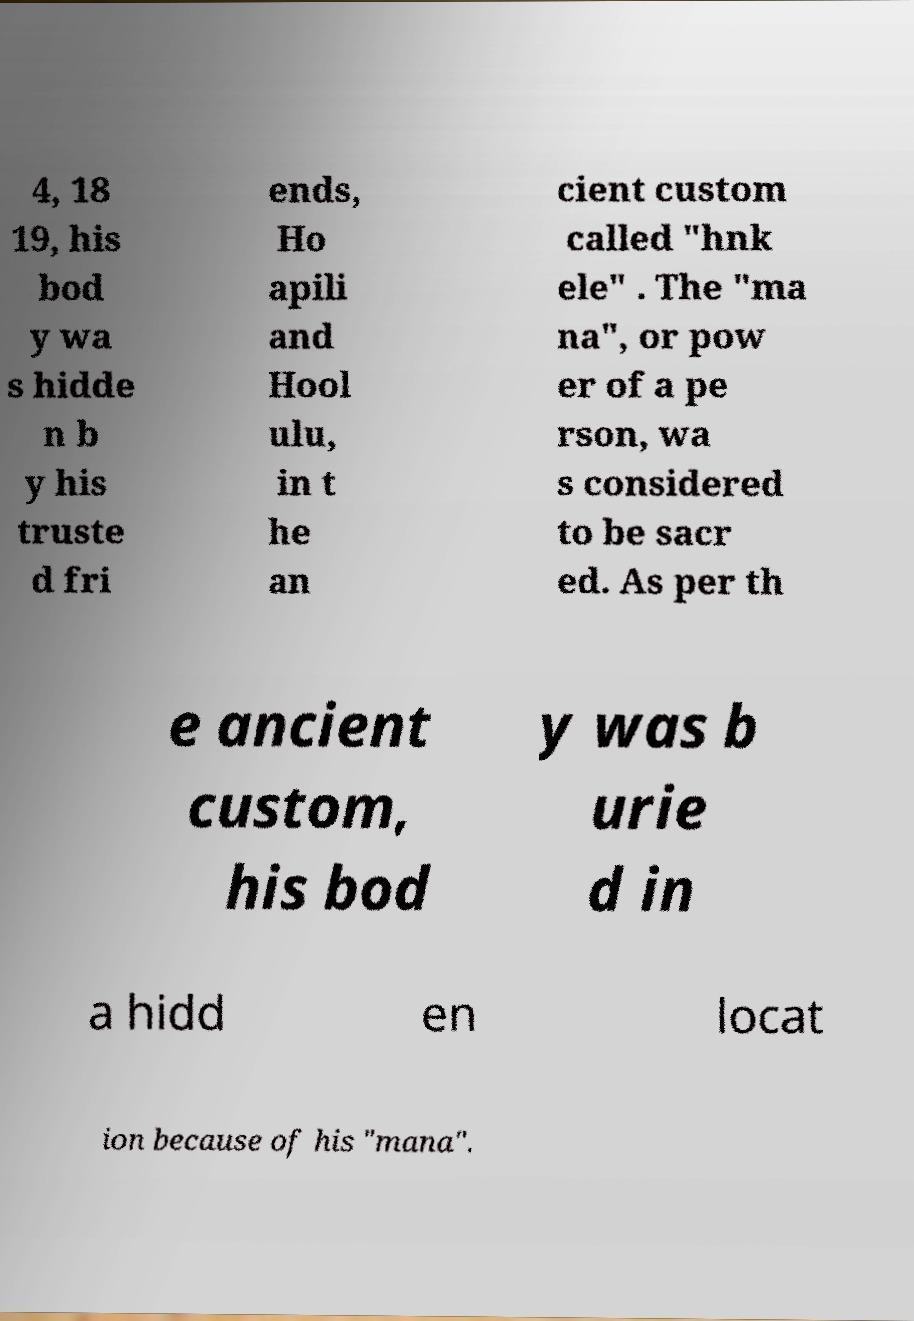Please read and relay the text visible in this image. What does it say? 4, 18 19, his bod y wa s hidde n b y his truste d fri ends, Ho apili and Hool ulu, in t he an cient custom called "hnk ele" . The "ma na", or pow er of a pe rson, wa s considered to be sacr ed. As per th e ancient custom, his bod y was b urie d in a hidd en locat ion because of his "mana". 